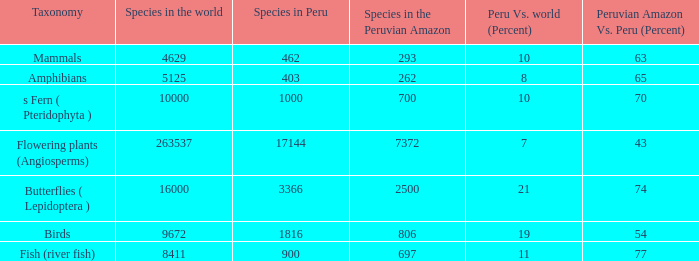What's the minimum species in the peruvian amazon with peru vs. world (percent) value of 7 7372.0. 